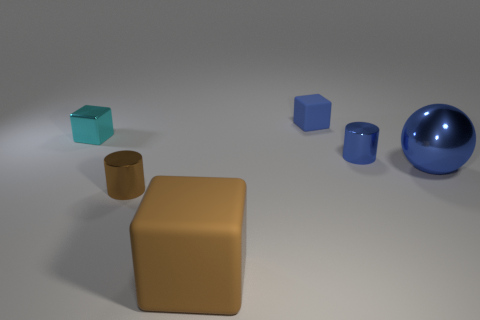What number of other things are made of the same material as the big brown thing?
Make the answer very short. 1. How big is the blue cube?
Provide a succinct answer. Small. How many other objects are the same color as the big metallic sphere?
Offer a terse response. 2. There is a thing that is right of the cyan metallic thing and to the left of the brown matte thing; what is its color?
Keep it short and to the point. Brown. What number of blue shiny cylinders are there?
Make the answer very short. 1. Does the blue ball have the same material as the large cube?
Your answer should be very brief. No. What is the shape of the large thing that is behind the metal cylinder that is in front of the small blue thing that is in front of the tiny matte block?
Provide a short and direct response. Sphere. Are the small cylinder that is right of the brown cube and the cube that is in front of the blue metal sphere made of the same material?
Your response must be concise. No. What is the material of the big blue thing?
Make the answer very short. Metal. How many other large things are the same shape as the big blue metal object?
Give a very brief answer. 0. 